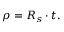Convert formula to latex. <formula><loc_0><loc_0><loc_500><loc_500>\rho = R _ { s } \cdot t .</formula> 